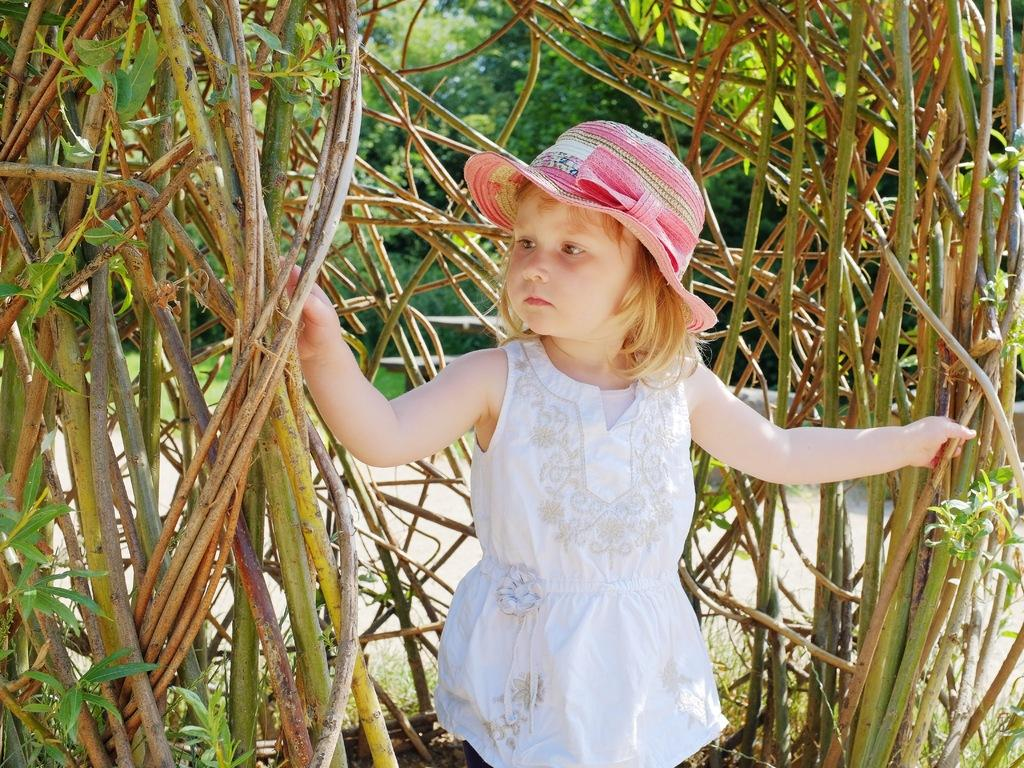What is the main subject of the image? There is a girl standing in the center of the image. What is the girl holding in the image? The girl is holding plants. What can be seen in the background of the image? There are trees in the background of the image. How many people are in the crowd surrounding the girl in the image? There is no crowd present in the image; it only features the girl holding plants. Is the girl in the image walking through a park during a rainstorm? There is no indication of a park or rainstorm in the image; it only shows the girl holding plants. 